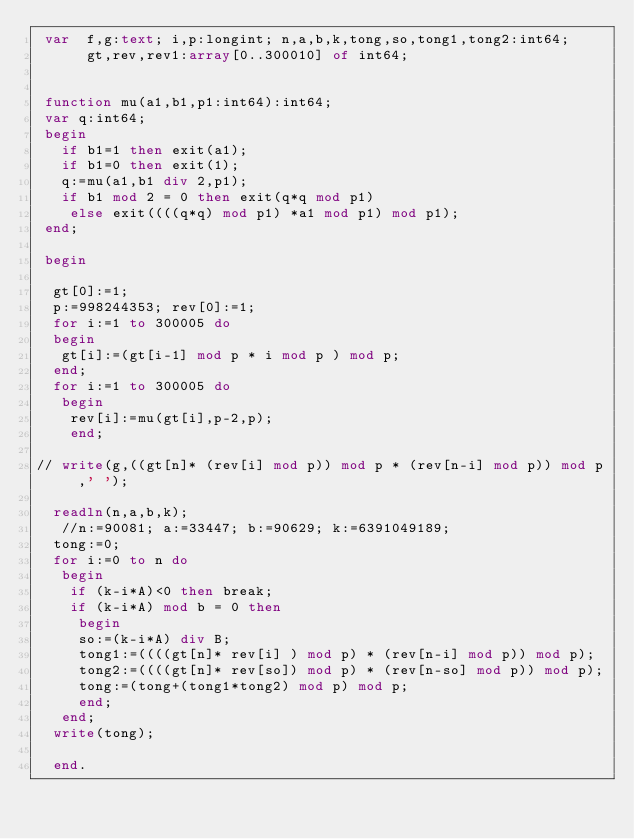<code> <loc_0><loc_0><loc_500><loc_500><_Pascal_> var  f,g:text; i,p:longint; n,a,b,k,tong,so,tong1,tong2:int64;
      gt,rev,rev1:array[0..300010] of int64;


 function mu(a1,b1,p1:int64):int64;
 var q:int64;
 begin
   if b1=1 then exit(a1);
   if b1=0 then exit(1);
   q:=mu(a1,b1 div 2,p1);
   if b1 mod 2 = 0 then exit(q*q mod p1)
    else exit((((q*q) mod p1) *a1 mod p1) mod p1);
 end;

 begin

  gt[0]:=1;
  p:=998244353; rev[0]:=1;
  for i:=1 to 300005 do
  begin
   gt[i]:=(gt[i-1] mod p * i mod p ) mod p;
  end;
  for i:=1 to 300005 do
   begin
    rev[i]:=mu(gt[i],p-2,p);
    end;

// write(g,((gt[n]* (rev[i] mod p)) mod p * (rev[n-i] mod p)) mod p ,' ');

  readln(n,a,b,k);
   //n:=90081; a:=33447; b:=90629; k:=6391049189;
  tong:=0;
  for i:=0 to n do
   begin
    if (k-i*A)<0 then break;
    if (k-i*A) mod b = 0 then
     begin
     so:=(k-i*A) div B;
     tong1:=((((gt[n]* rev[i] ) mod p) * (rev[n-i] mod p)) mod p);
     tong2:=((((gt[n]* rev[so]) mod p) * (rev[n-so] mod p)) mod p);
     tong:=(tong+(tong1*tong2) mod p) mod p;
     end;
   end;
  write(tong);

  end.</code> 